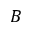<formula> <loc_0><loc_0><loc_500><loc_500>B</formula> 